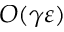<formula> <loc_0><loc_0><loc_500><loc_500>O ( \gamma \varepsilon )</formula> 